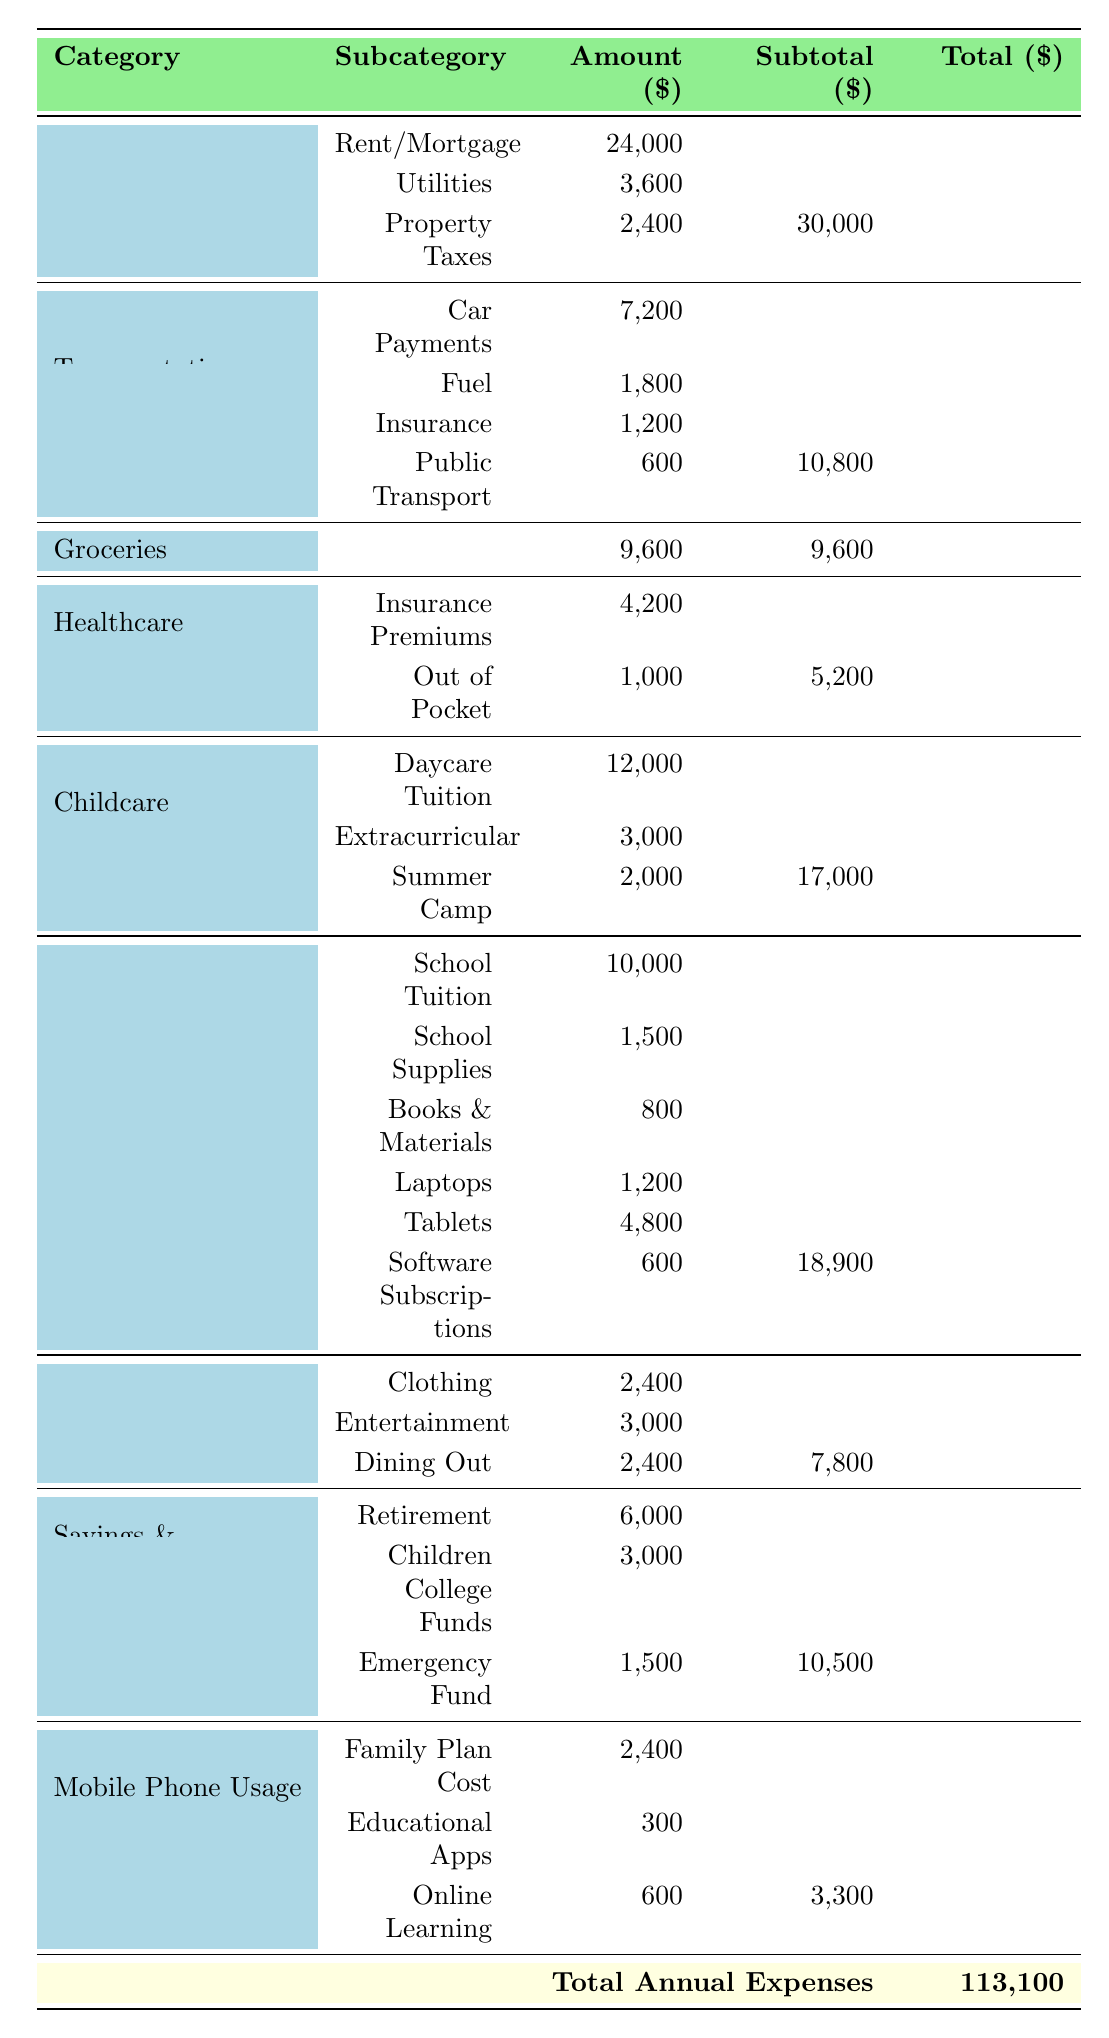What is the total expenditure on child-related expenses? To find the total child-related expenses, sum up the amounts in the Childcare and Education categories: Childcare Total = 12,000 + 3,000 + 2,000 = 17,000; Education Total = 10,000 + 1,500 + 800 + 1,200 + 4,800 + 600 = 18,900. Therefore, Total Child-Related Expenses = 17,000 + 18,900 = 35,900.
Answer: 35,900 What is the amount allocated for healthcare insurance premiums? The table directly states that the healthcare insurance premiums amount is 4,200.
Answer: 4,200 Are the total annual expenses greater than the total annual income? The total annual expenses listed is 113,100, and the total annual income is 80,000. Since 113,100 is greater than 80,000, the statement is true.
Answer: Yes How much is spent on transportation in total? The total transportation expenses are calculated by summing the individual transportation costs: 7,200 + 1,800 + 1,200 + 600 = 10,800.
Answer: 10,800 What percentage of total annual income is spent on education? To find the percentage spent on education, first determine the total education expenses, which is 18,900. Then, calculate the percentage by dividing the education total by the total annual income: (18,900 / 80,000) * 100 = 23.625%.
Answer: 23.625% What is the difference between total housing expenses and total savings and investment expenses? First, calculate the total housing expenses: 24,000 + 3,600 + 2,400 = 30,000. Next, calculate total savings and investment expenses: 6,000 + 3,000 + 1,500 = 10,500. Now find the difference: 30,000 - 10,500 = 19,500.
Answer: 19,500 What is the total spent on mobile phone usage and how does it compare to educational apps and services? For mobile phone usage, the total is 2,400 + 300 + 600 = 3,300. Comparing this with educational apps and services, which totaled to 900 (300 for apps + 600 for online learning), we see that 3,300 is significantly higher than 900.
Answer: 3,300; higher How much do the average screen time hours for children and parents add up to? The children's average screen time is 4 hours, and the parents' average is 3 hours. Adding these together gives: 4 + 3 = 7 hours.
Answer: 7 What is the total expenditure categorized under personal expenses? The total under personal expenses is calculated by adding all the items: 2,400 + 3,000 + 2,400 = 7,800.
Answer: 7,800 Is the total amount allocated for books and materials more than for school supplies? The total for books and materials is 800, and for school supplies, it is 1,500. Since 800 is less than 1,500, the statement is false.
Answer: No 